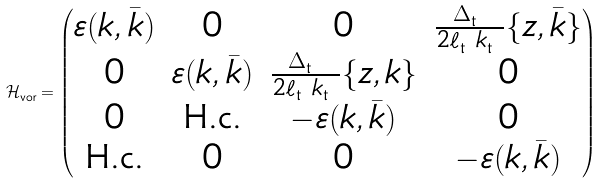Convert formula to latex. <formula><loc_0><loc_0><loc_500><loc_500>\mathcal { H } ^ { \ } _ { \text {vor} } = \begin{pmatrix} \varepsilon ( k , \bar { k } ) & 0 & 0 & \frac { \Delta ^ { \ } _ { \text {t} } } { 2 \ell ^ { \ } _ { \text {t} } k ^ { \ } _ { \text {t} } } \{ z , \bar { k } \} \\ 0 & \varepsilon ( k , \bar { k } ) & \frac { \Delta ^ { \ } _ { \text {t} } } { 2 \ell ^ { \ } _ { \text {t} } k ^ { \ } _ { \text {t} } } \{ z , k \} & 0 \\ 0 & \text {H.c.} & - \varepsilon ( k , \bar { k } ) & 0 \\ \text {H.c.} & 0 & 0 & - \varepsilon ( k , \bar { k } ) \end{pmatrix}</formula> 